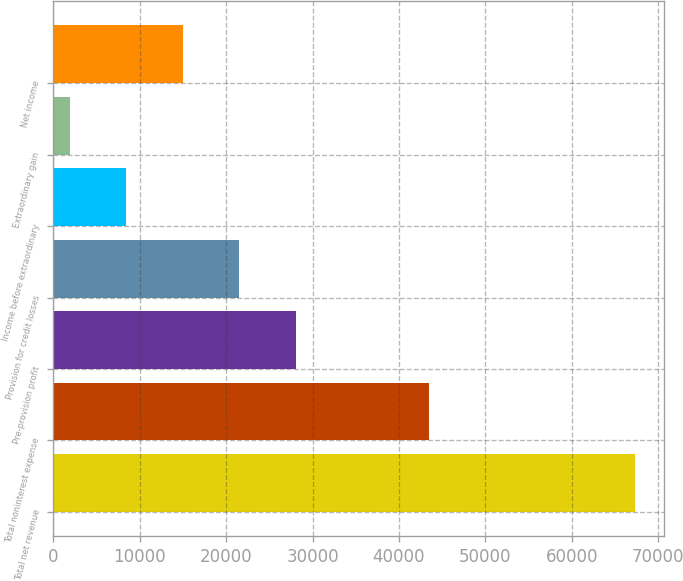<chart> <loc_0><loc_0><loc_500><loc_500><bar_chart><fcel>Total net revenue<fcel>Total noninterest expense<fcel>Pre-provision profit<fcel>Provision for credit losses<fcel>Income before extraordinary<fcel>Extraordinary gain<fcel>Net income<nl><fcel>67252<fcel>43500<fcel>28044.4<fcel>21509.8<fcel>8440.6<fcel>1906<fcel>14975.2<nl></chart> 